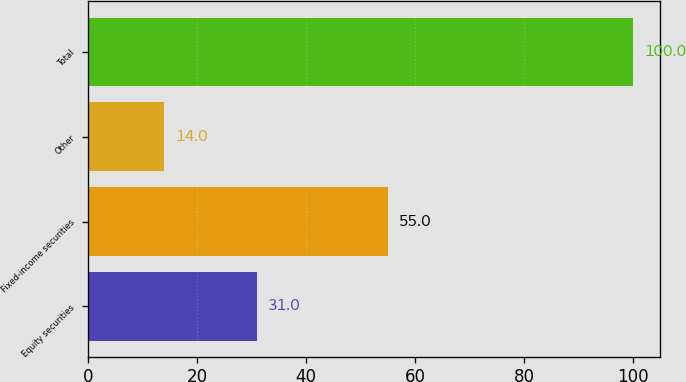<chart> <loc_0><loc_0><loc_500><loc_500><bar_chart><fcel>Equity securities<fcel>Fixed-income securities<fcel>Other<fcel>Total<nl><fcel>31<fcel>55<fcel>14<fcel>100<nl></chart> 